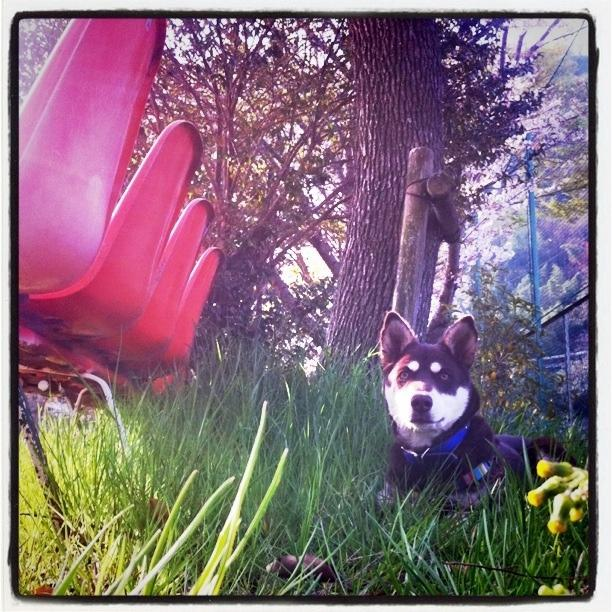What item is in the wrong setting?

Choices:
A) dog
B) tree
C) chairs
D) grass chairs 